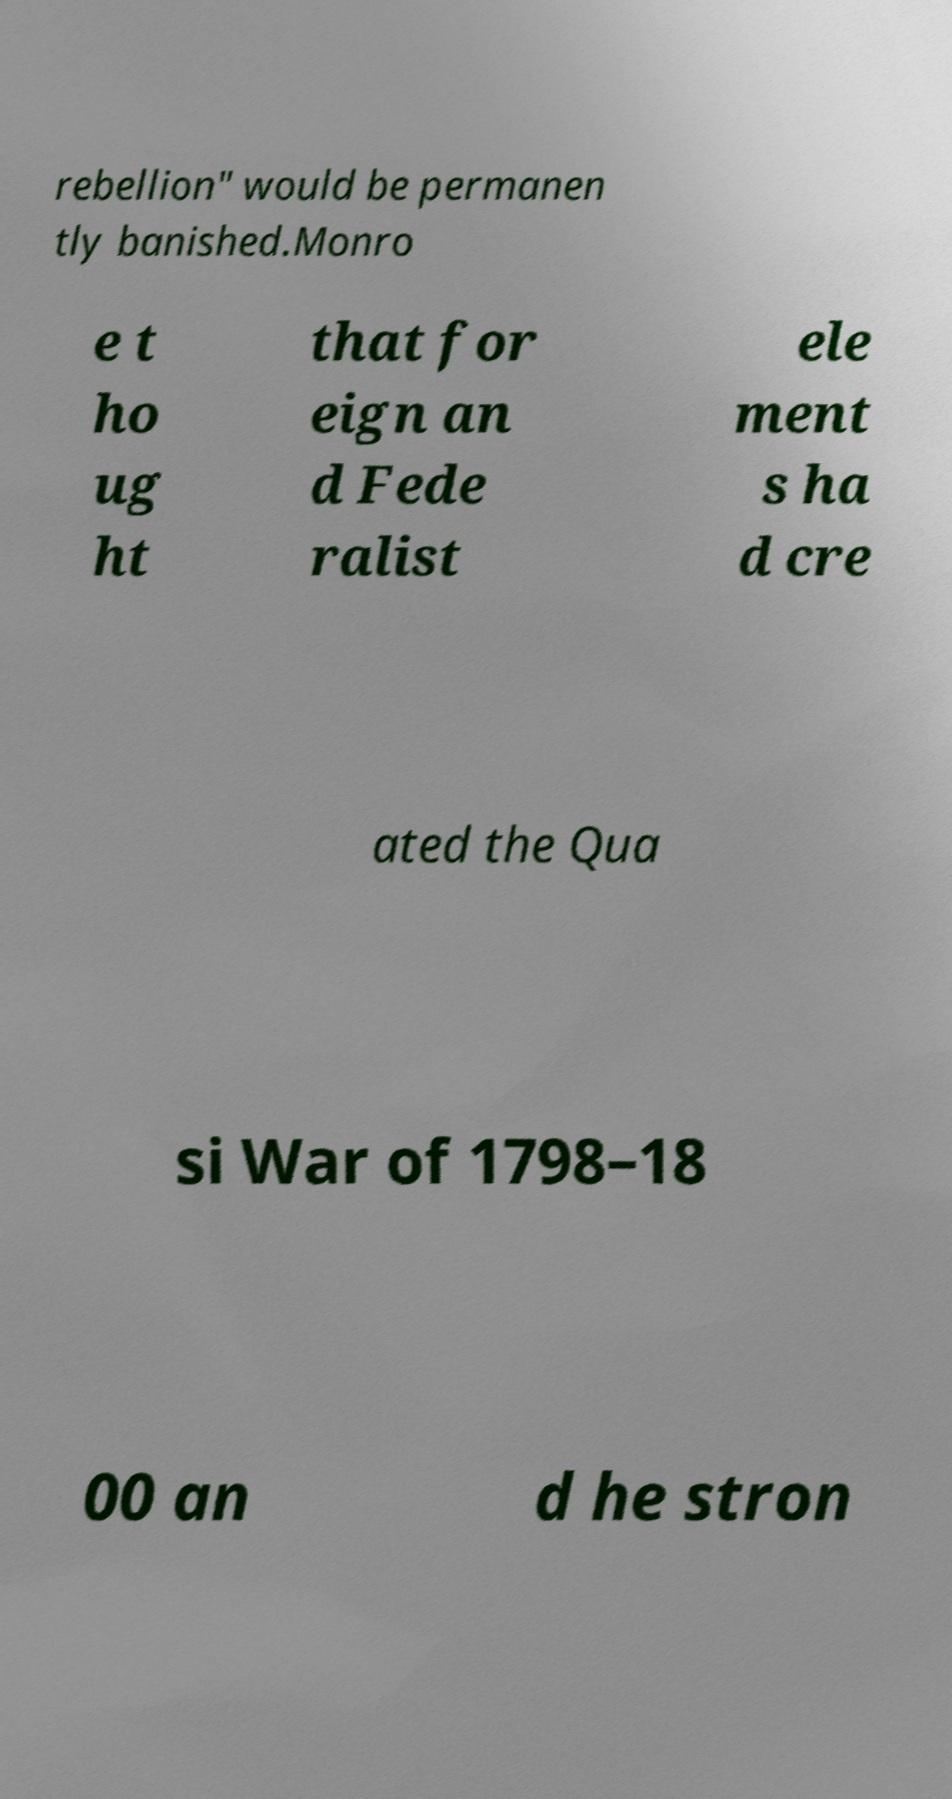Can you accurately transcribe the text from the provided image for me? rebellion" would be permanen tly banished.Monro e t ho ug ht that for eign an d Fede ralist ele ment s ha d cre ated the Qua si War of 1798–18 00 an d he stron 